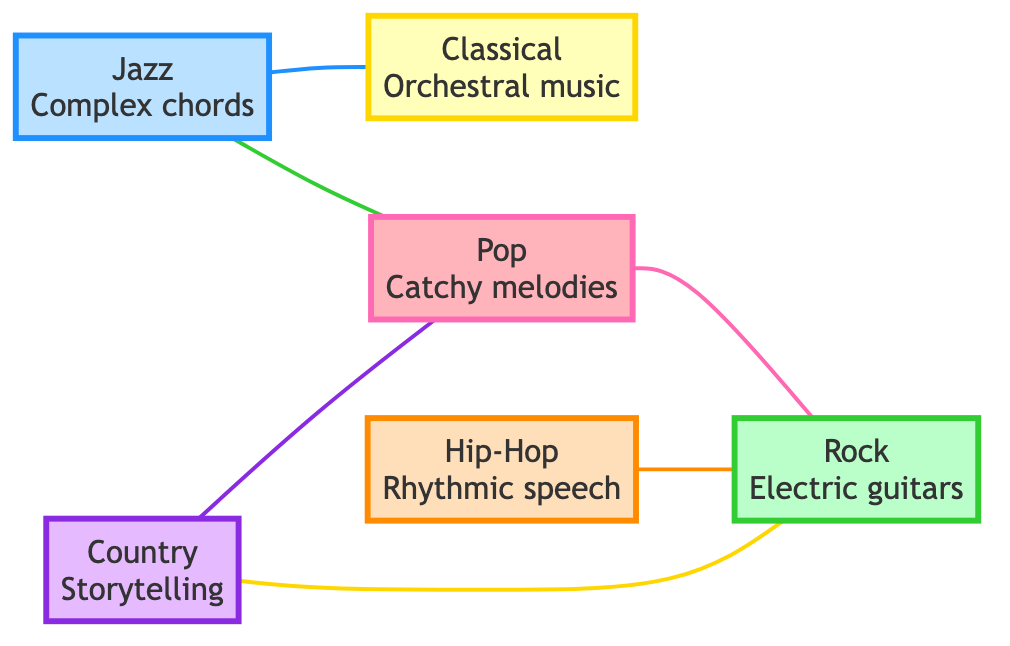What is the total number of musical genres represented in the graph? The nodes in the diagram represent different musical genres. By counting these nodes, we can determine that there are a total of 6 genres: Pop, Rock, Jazz, Classical, Hip-Hop, and Country.
Answer: 6 Which genre is described as featuring complex chords and improvisation? By examining the nodes, we find that Jazz is described specifically for its complex chords and improvisation, as denoted in its description.
Answer: Jazz What types of music share a direct relationship with Pop in the graph? The edges connecting to the Pop node show that it has direct relationships with Rock and Country, as well as with Jazz, since these genres are mentioned in the edges connecting to Pop.
Answer: Rock, Country, Jazz How do Hip-Hop and Rock relate in the diagram? The edge connecting Hip-Hop and Rock indicates that they are connected through fusion genres like Rap Rock. This relationship is a direct connection as specified in the diagram.
Answer: Fusion genres like Rap Rock Which genre requires technical musicianship and is related to Jazz? Looking at the edge and node connections, Classical is connected to Jazz and is described as requiring technical musicianship, making Classical the answer.
Answer: Classical Which two genres combine storytelling and catchy elements? The edges connecting Country and Pop indicate that Country Pop blends the storytelling characteristics of Country with the catchy aspects of Pop, thus answering the question.
Answer: Country Pop How many relationships involve Rock in the graph? By reviewing the edges, we identify three connections: Rock connects to Pop, Hip-Hop, and Country. Counting all these connections, we find there are three relationships involving Rock.
Answer: 3 What genre is known for its orchestral music? Referring to the nodes, we see that Classical is described as having orchestral music, indicating that this is the genre known for such features.
Answer: Classical Which two genres are directly connected through improvisation? The node Jazz is directly connected to Classical, and since Jazz is characterized by improvisation, the relationship verifies that these two genres share this direct connection through their complexities.
Answer: Jazz, Classical 